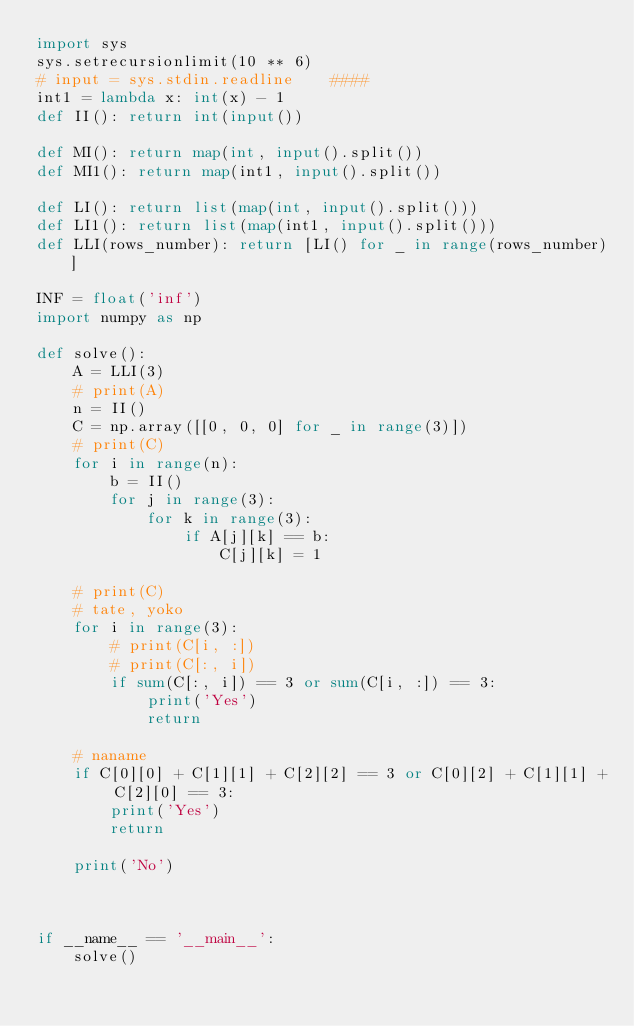Convert code to text. <code><loc_0><loc_0><loc_500><loc_500><_Python_>import sys
sys.setrecursionlimit(10 ** 6)
# input = sys.stdin.readline    ####
int1 = lambda x: int(x) - 1
def II(): return int(input())

def MI(): return map(int, input().split())
def MI1(): return map(int1, input().split())

def LI(): return list(map(int, input().split()))
def LI1(): return list(map(int1, input().split()))
def LLI(rows_number): return [LI() for _ in range(rows_number)]

INF = float('inf')
import numpy as np

def solve():
    A = LLI(3)
    # print(A)
    n = II()
    C = np.array([[0, 0, 0] for _ in range(3)])
    # print(C)
    for i in range(n):
        b = II()
        for j in range(3):
            for k in range(3):
                if A[j][k] == b:
                    C[j][k] = 1

    # print(C)
    # tate, yoko
    for i in range(3):
        # print(C[i, :])
        # print(C[:, i])
        if sum(C[:, i]) == 3 or sum(C[i, :]) == 3:
            print('Yes')
            return

    # naname
    if C[0][0] + C[1][1] + C[2][2] == 3 or C[0][2] + C[1][1] + C[2][0] == 3:
        print('Yes')
        return

    print('No')



if __name__ == '__main__':
    solve()
</code> 